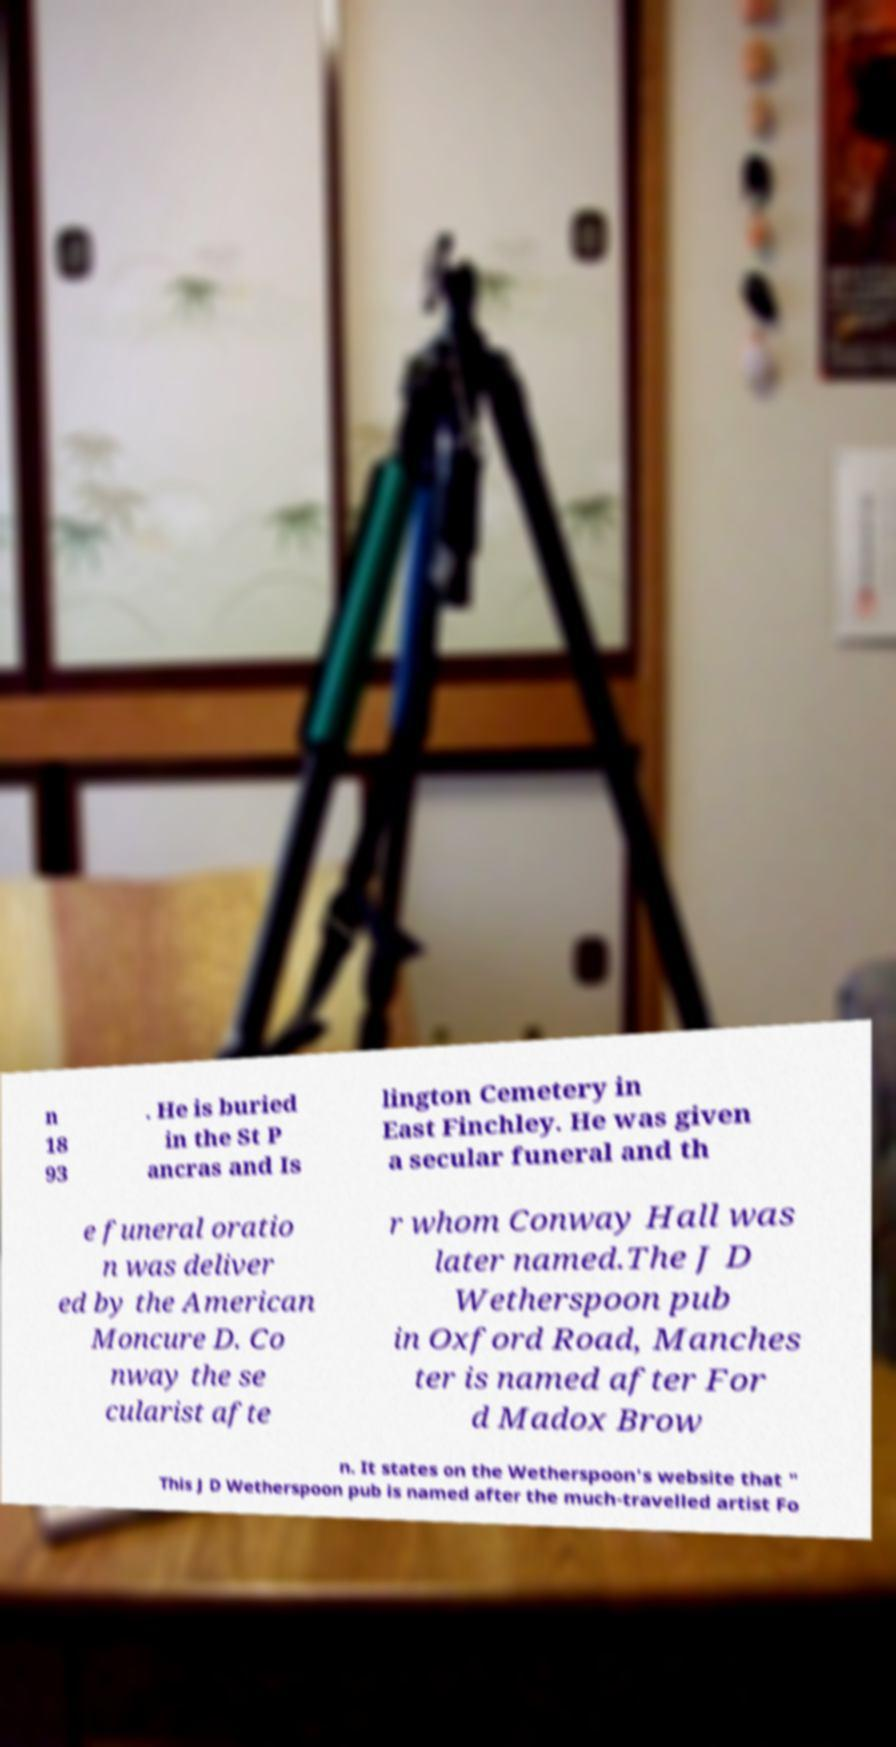Can you read and provide the text displayed in the image?This photo seems to have some interesting text. Can you extract and type it out for me? n 18 93 . He is buried in the St P ancras and Is lington Cemetery in East Finchley. He was given a secular funeral and th e funeral oratio n was deliver ed by the American Moncure D. Co nway the se cularist afte r whom Conway Hall was later named.The J D Wetherspoon pub in Oxford Road, Manches ter is named after For d Madox Brow n. It states on the Wetherspoon's website that " This J D Wetherspoon pub is named after the much-travelled artist Fo 